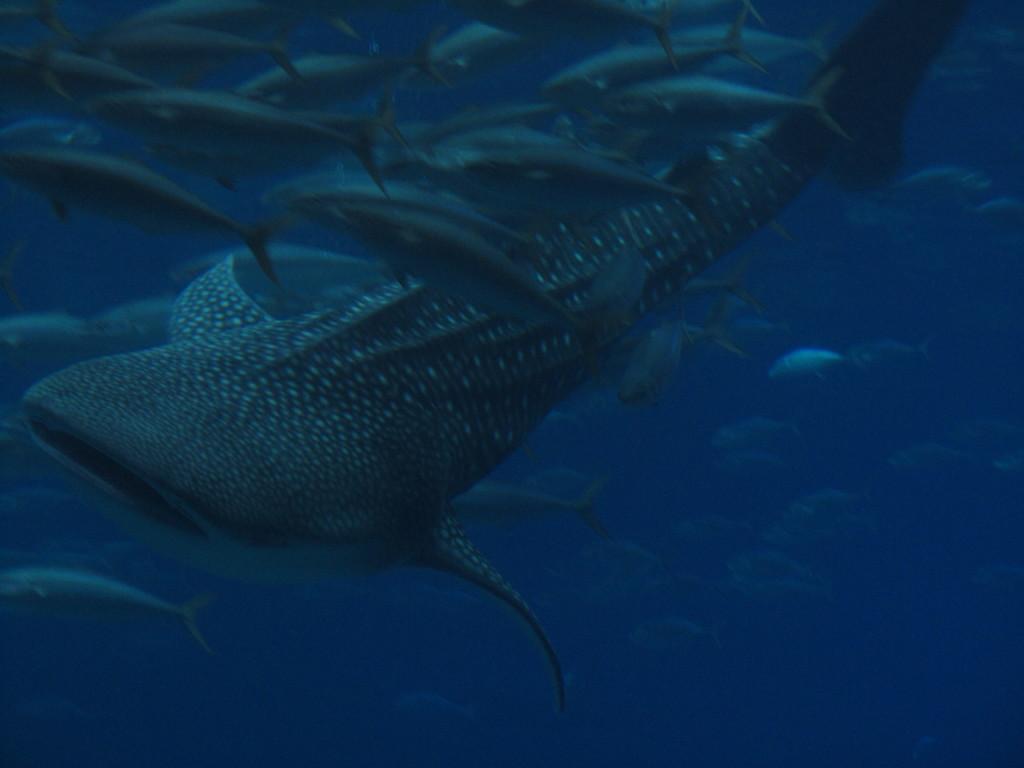Could you give a brief overview of what you see in this image? In this image we can see some fish under the water. 